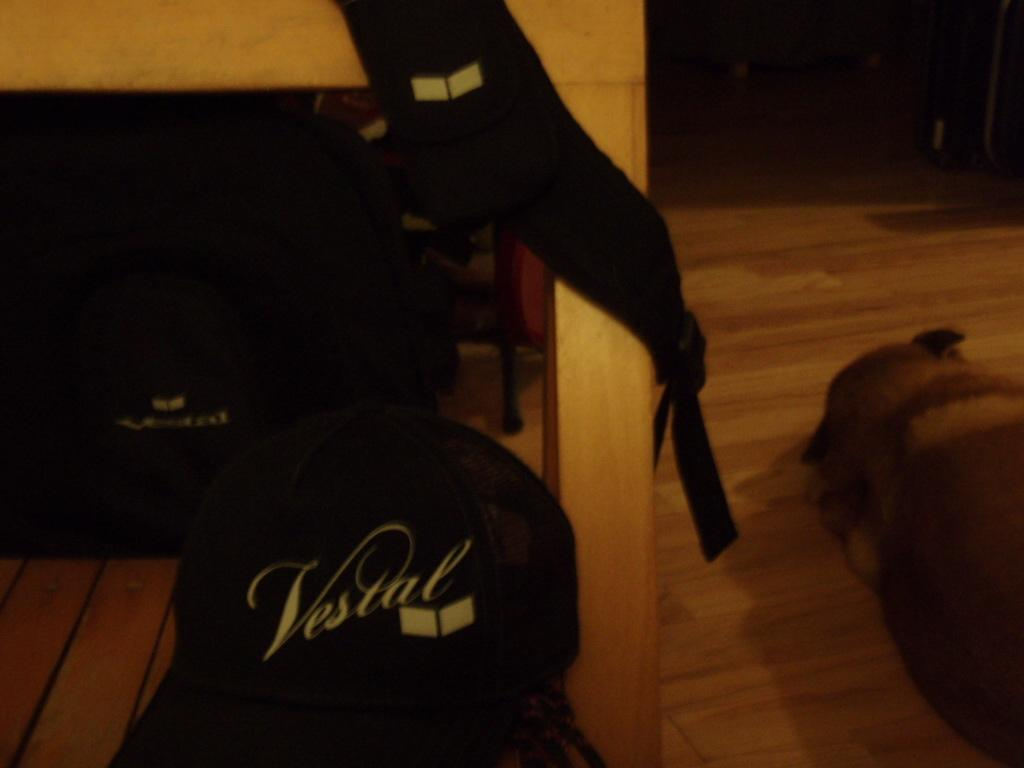What animal can be seen in the image? There is a dog in the image. What position is the dog in? The dog is laying on the floor. What can be observed about the background of the image? The background of the image is dark. Can you see a tiger in the image? No, there is no tiger present in the image; it features a dog laying on the floor. 